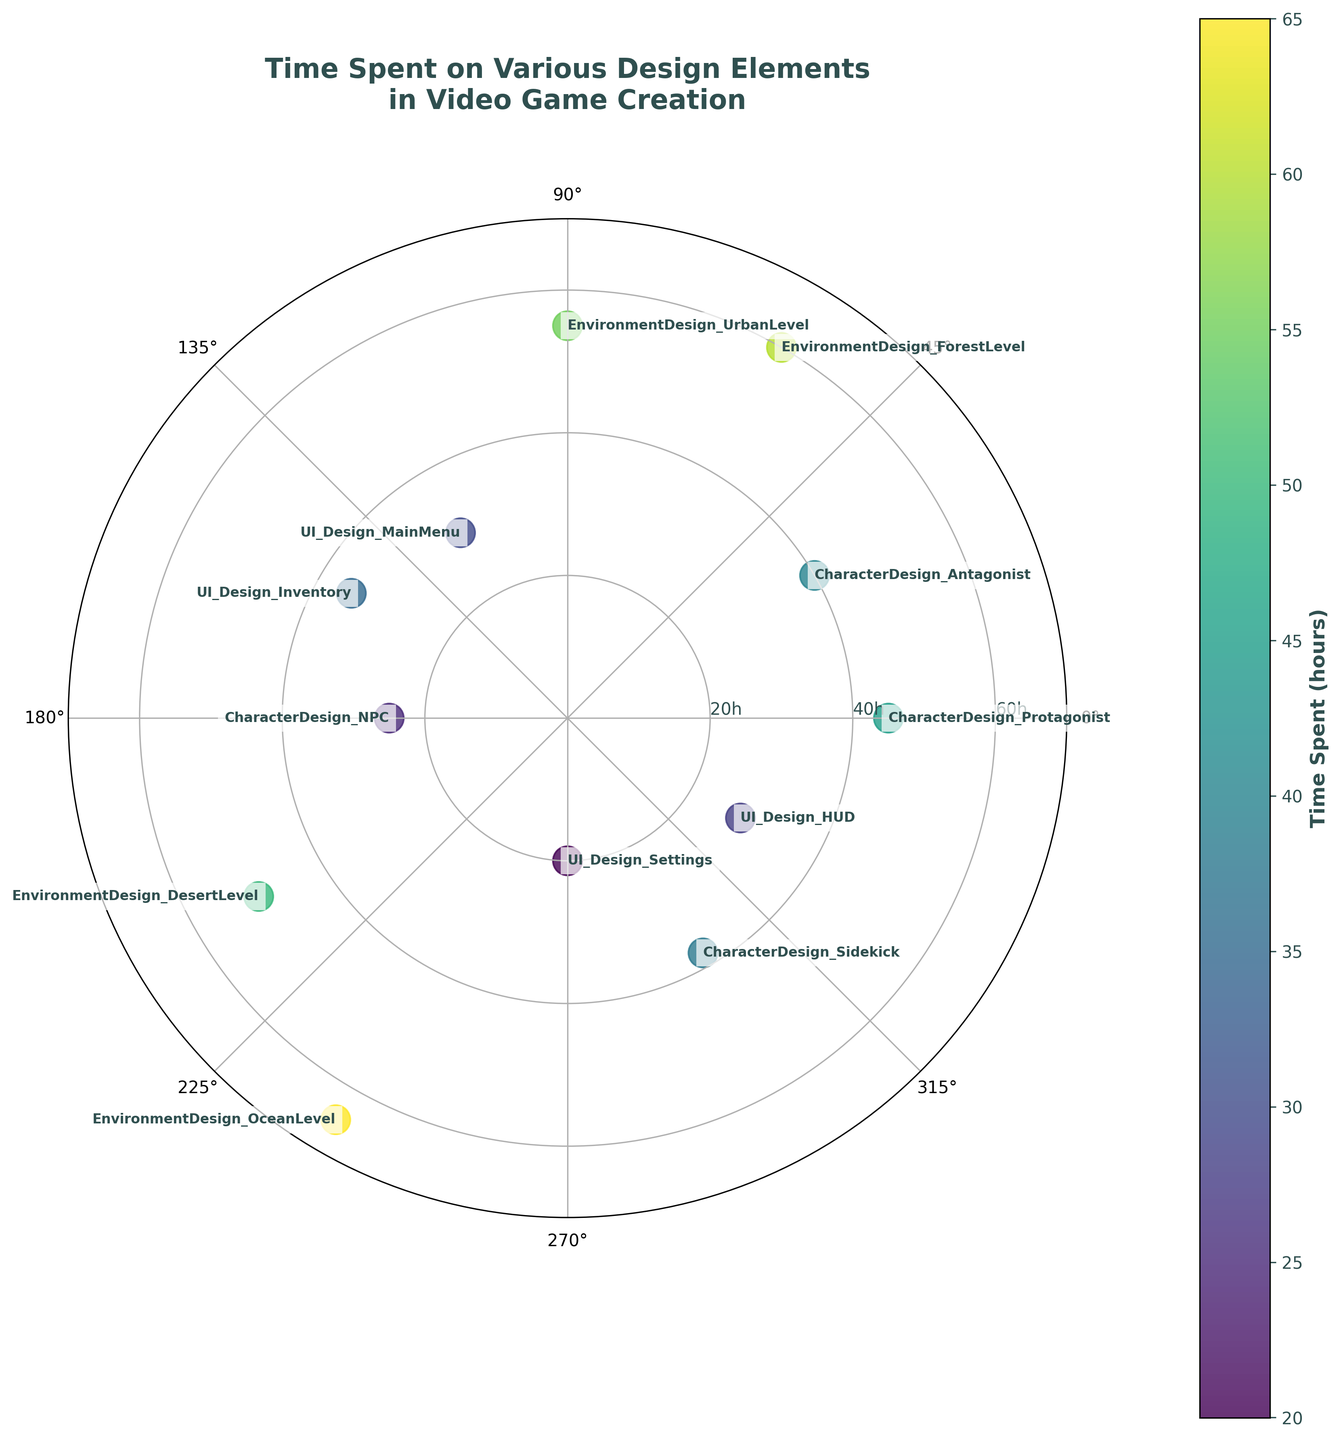What is the title of the chart? The title is located at the top of the chart and reads as: "Time Spent on Various Design Elements in Video Game Creation."
Answer: Time Spent on Various Design Elements in Video Game Creation How many design elements are represented in the chart? Count the number of distinct points on the polar scatter chart, each point corresponds to a design element. There are 12 points representing 12 design elements.
Answer: 12 What color represents the design element where the most time was spent? The design element with the most time spent is colored in the darkest shade as per the viridis colormap used. The "EnvironmentDesign_OceanLevel" at 65 hours has the darkest shade.
Answer: Darkest shade Which design element took the least amount of time? Look for the data point that is closest to the center of the polar scatter chart, indicating the smallest radius value. "UI_Design_Settings" took 20 hours, which is the least time spent.
Answer: UI_Design_Settings What is the range of time spent on the design elements? Find the minimum and maximum values on the radial axis. The minimum and maximum values for time spent are 20 hours and 65 hours respectively. Calculate the range as maximum minus minimum.
Answer: 45 hours (65 - 20) How much more time was spent on "CharacterDesign_Protagonist" compared to "CharacterDesign_NPC"? Find the radial distance for both design elements on the chart. "CharacterDesign_Protagonist" took 45 hours and "CharacterDesign_NPC" took 25 hours. The difference is 45 - 25 = 20 hours.
Answer: 20 hours Which design element(s) spent more than 50 hours on? Look for all the data points with radial distance greater than 50 hours. These would be "EnvironmentDesign_ForestLevel" (60 hours), "EnvironmentDesign_UrbanLevel" (55 hours), "EnvironmentDesign_DesertLevel" (50 hours), and "EnvironmentDesign_OceanLevel" (65 hours).
Answer: EnvironmentDesign_ForestLevel, EnvironmentDesign_UrbanLevel, EnvironmentDesign_DesertLevel, EnvironmentDesign_OceanLevel What is the average time spent on UI Design elements? Sum the times spent on all UI Design elements and divide by the number of these elements. Times are: 30, 35, 20, 28. The sum is 30+35+20+28=113 and there are 4 elements. Therefore, the average is 113/4 = 28.25 hours.
Answer: 28.25 hours Which design category, among Characters, Environments, or UI, had the highest total time spent? Sum the times for each category: Characters (45+40+25+38=148), Environments (60+55+50+65=230), and UI (30+35+20+28=113). Compare the sums, and Environments spent the most time total.
Answer: Environments What is the approximate central angle in degrees between "CharacterDesign_Protagonist" and "CharacterDesign_NPC"? Count the data points to locate positions. There are 12 equal segments in the circle (360 degrees) so each segment is 360/12 = 30 degrees. "CharacterDesign_Protagonist" and "CharacterDesign_NPC" are adjacent, thus the angle is 30 degrees.
Answer: 30 degrees 